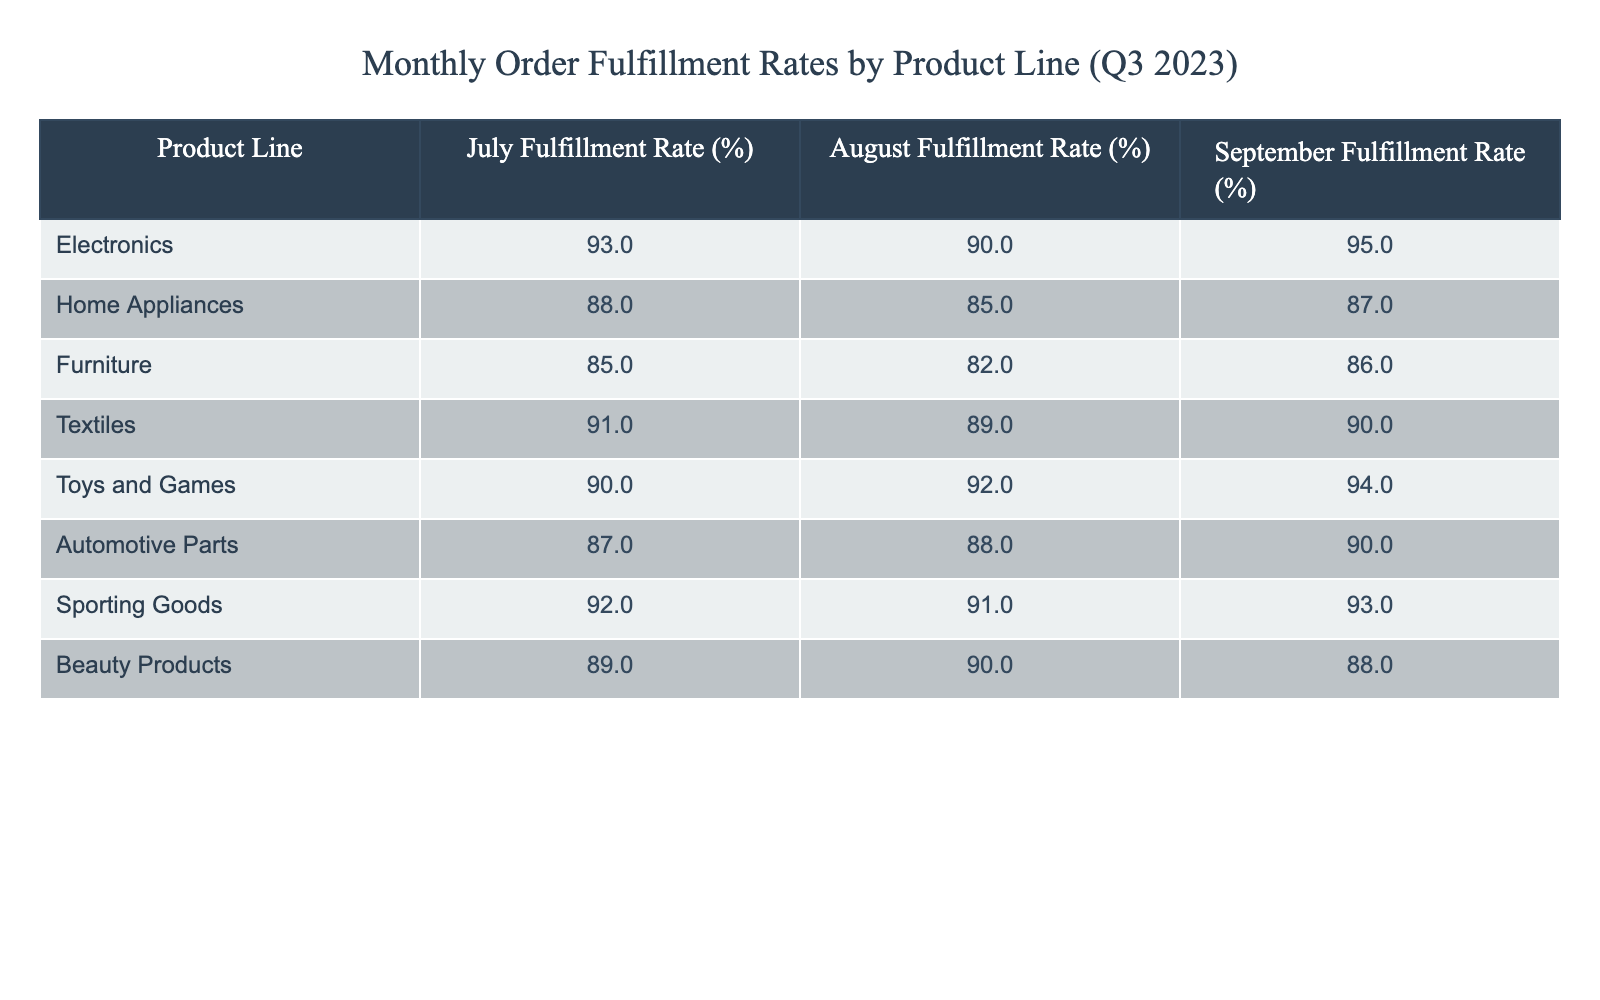What was the fulfillment rate for Home Appliances in September 2023? The table shows the fulfillment rate for Home Appliances specifically for September, which is directly listed under the "September Fulfillment Rate (%)" column. The value is 87.
Answer: 87 Which product line had the highest fulfillment rate in July 2023? By examining the July fulfillment rates, we see the values for all product lines. The highest value is in Electronics at 93%.
Answer: Electronics What is the average fulfillment rate for Toys and Games over the three months? To calculate the average, we add the fulfillment rates for Toys and Games: (90 + 92 + 94) = 276. We then divide by 3 to get the average: 276/3 = 92.
Answer: 92 Did the fulfillment rate for Beauty Products increase in August 2023 compared to July 2023? We compare the fulfillment rates for Beauty Products in both months. The rate was 89% in July and decreased to 90% in August, indicating an increase.
Answer: Yes What is the difference between the September fulfillment rates of Sporting Goods and Automotive Parts? We find the fulfillment rate for Sporting Goods in September, which is 93%, and for Automotive Parts, which is 90%. The difference is 93% - 90% = 3%.
Answer: 3% Which product line has the most consistent fulfillment rates, with the smallest variance from month to month? We need to evaluate the rates for each product line over the three months and calculate their ranges. The product line with the smallest change is evaluated, and in this case, it is Beauty Products: (89, 90, 88) - the range is 2.
Answer: Beauty Products What was the highest month-to-month increase in fulfillment rates for any product line from July to August? To find this, we look at the month-to-month changes for each product line. The values are as follows: Electronics (93 to 90 decrease), Home Appliances (88 to 85 decrease), Furniture (85 to 82 decrease), Textiles (91 to 89 decrease), Toys and Games (90 to 92 increase of 2), Automotive Parts (87 to 88 increase of 1), Sporting Goods (92 to 91 decrease), and Beauty Products (89 to 90 increase of 1). The largest increase was Toys and Games at 2%.
Answer: 2% Is Toys and Games the only product line with a fulfillment rate above 90% in September? By checking the fulfillment rates for September across all lines, Toys and Games is at 94%, while Electronics is at 95%, so it is not the only one over 90%.
Answer: No Which product line showed the largest decrease in fulfillment rate from July to September? We compare the July and September rates for all product lines. Electronics went from 93% to 95% (increase), Home Appliances from 88% to 87% (decrease of 1), Furniture from 85% to 86% (increase), Textiles from 91% to 90% (decrease of 1), Toys and Games from 90% to 94% (increase), Automotive Parts from 87% to 90% (increase), Sporting Goods from 92% to 93% (increase), Beauty Products from 89% to 88% (decrease of 1). The largest decrease is 1% for Home Appliances, Textiles, and Beauty Products.
Answer: Home Appliances, Textiles, Beauty Products 